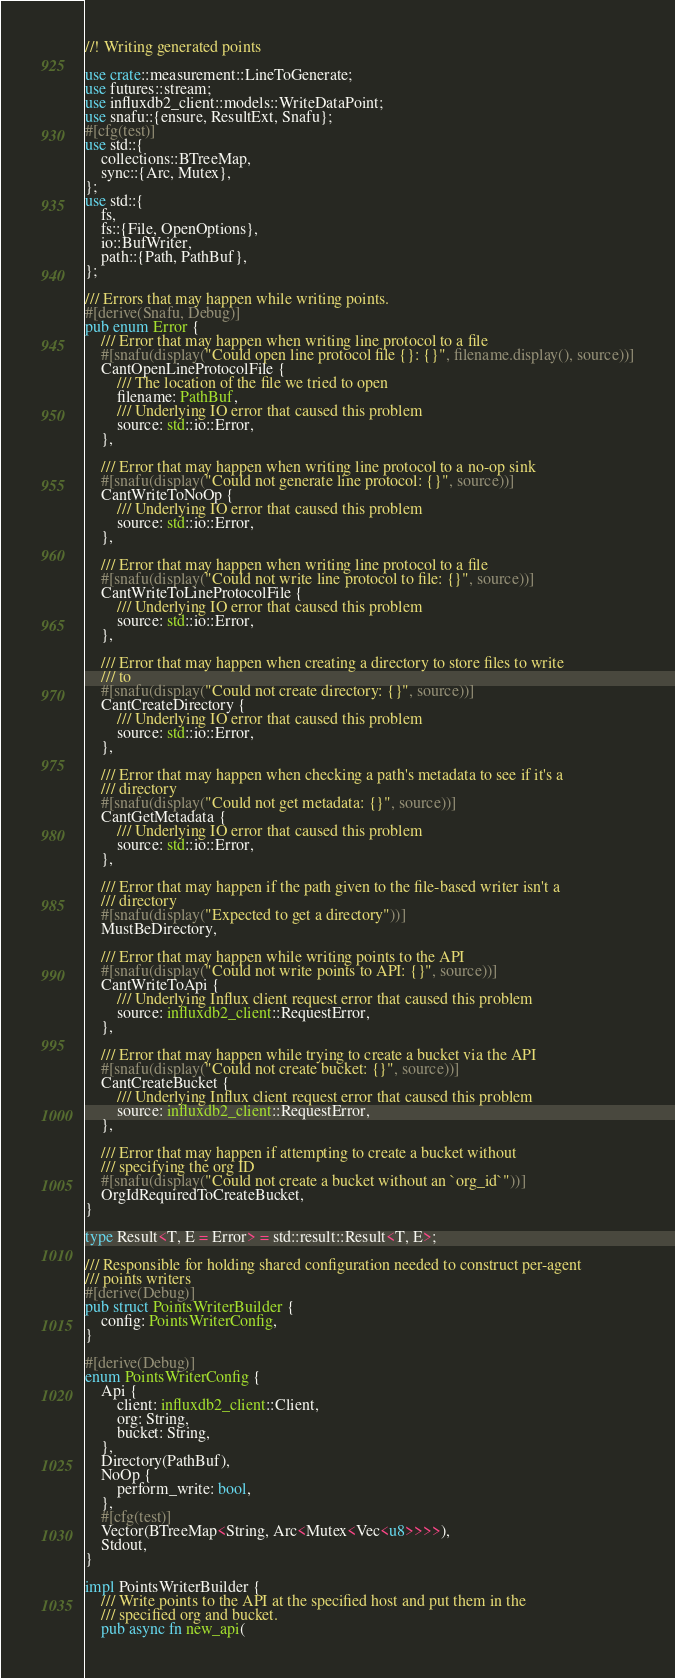Convert code to text. <code><loc_0><loc_0><loc_500><loc_500><_Rust_>//! Writing generated points

use crate::measurement::LineToGenerate;
use futures::stream;
use influxdb2_client::models::WriteDataPoint;
use snafu::{ensure, ResultExt, Snafu};
#[cfg(test)]
use std::{
    collections::BTreeMap,
    sync::{Arc, Mutex},
};
use std::{
    fs,
    fs::{File, OpenOptions},
    io::BufWriter,
    path::{Path, PathBuf},
};

/// Errors that may happen while writing points.
#[derive(Snafu, Debug)]
pub enum Error {
    /// Error that may happen when writing line protocol to a file
    #[snafu(display("Could open line protocol file {}: {}", filename.display(), source))]
    CantOpenLineProtocolFile {
        /// The location of the file we tried to open
        filename: PathBuf,
        /// Underlying IO error that caused this problem
        source: std::io::Error,
    },

    /// Error that may happen when writing line protocol to a no-op sink
    #[snafu(display("Could not generate line protocol: {}", source))]
    CantWriteToNoOp {
        /// Underlying IO error that caused this problem
        source: std::io::Error,
    },

    /// Error that may happen when writing line protocol to a file
    #[snafu(display("Could not write line protocol to file: {}", source))]
    CantWriteToLineProtocolFile {
        /// Underlying IO error that caused this problem
        source: std::io::Error,
    },

    /// Error that may happen when creating a directory to store files to write
    /// to
    #[snafu(display("Could not create directory: {}", source))]
    CantCreateDirectory {
        /// Underlying IO error that caused this problem
        source: std::io::Error,
    },

    /// Error that may happen when checking a path's metadata to see if it's a
    /// directory
    #[snafu(display("Could not get metadata: {}", source))]
    CantGetMetadata {
        /// Underlying IO error that caused this problem
        source: std::io::Error,
    },

    /// Error that may happen if the path given to the file-based writer isn't a
    /// directory
    #[snafu(display("Expected to get a directory"))]
    MustBeDirectory,

    /// Error that may happen while writing points to the API
    #[snafu(display("Could not write points to API: {}", source))]
    CantWriteToApi {
        /// Underlying Influx client request error that caused this problem
        source: influxdb2_client::RequestError,
    },

    /// Error that may happen while trying to create a bucket via the API
    #[snafu(display("Could not create bucket: {}", source))]
    CantCreateBucket {
        /// Underlying Influx client request error that caused this problem
        source: influxdb2_client::RequestError,
    },

    /// Error that may happen if attempting to create a bucket without
    /// specifying the org ID
    #[snafu(display("Could not create a bucket without an `org_id`"))]
    OrgIdRequiredToCreateBucket,
}

type Result<T, E = Error> = std::result::Result<T, E>;

/// Responsible for holding shared configuration needed to construct per-agent
/// points writers
#[derive(Debug)]
pub struct PointsWriterBuilder {
    config: PointsWriterConfig,
}

#[derive(Debug)]
enum PointsWriterConfig {
    Api {
        client: influxdb2_client::Client,
        org: String,
        bucket: String,
    },
    Directory(PathBuf),
    NoOp {
        perform_write: bool,
    },
    #[cfg(test)]
    Vector(BTreeMap<String, Arc<Mutex<Vec<u8>>>>),
    Stdout,
}

impl PointsWriterBuilder {
    /// Write points to the API at the specified host and put them in the
    /// specified org and bucket.
    pub async fn new_api(</code> 